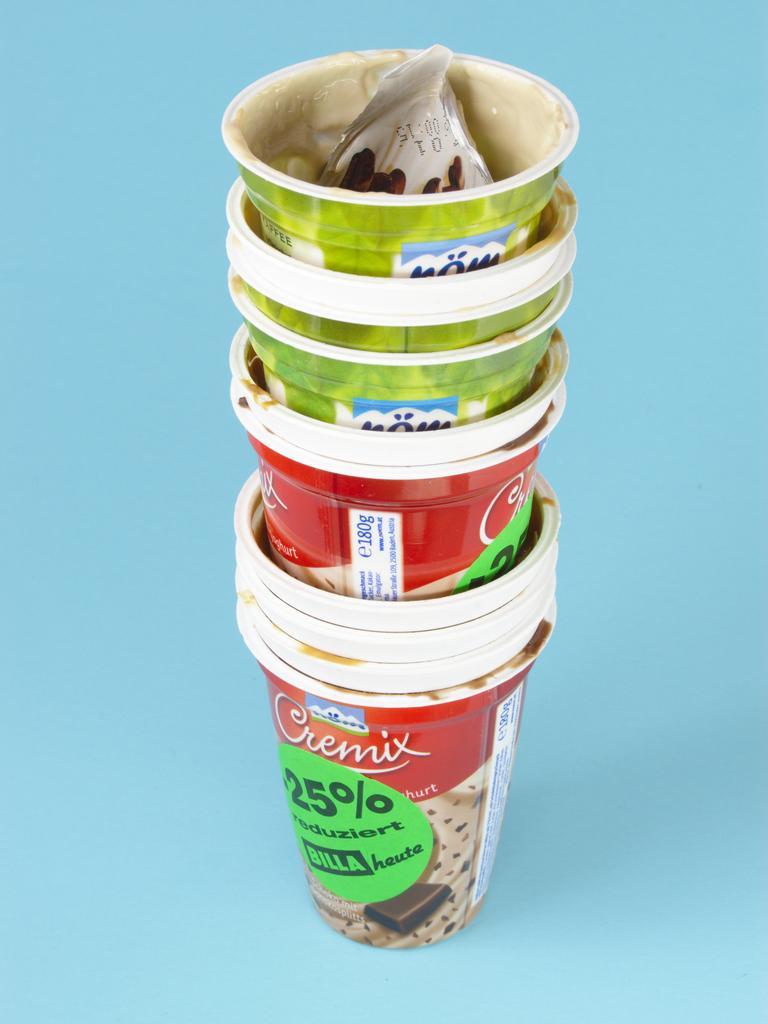How would you summarize this image in a sentence or two? In this picture we can see plastic glasses on the blue surface. 